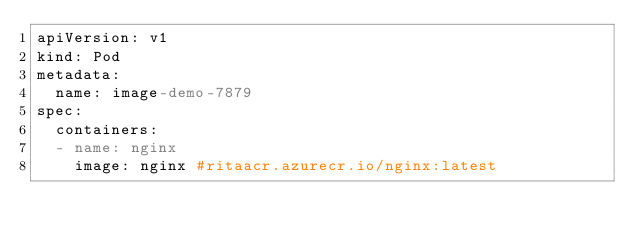Convert code to text. <code><loc_0><loc_0><loc_500><loc_500><_YAML_>apiVersion: v1
kind: Pod
metadata:
  name: image-demo-7879
spec:
  containers:
  - name: nginx
    image: nginx #ritaacr.azurecr.io/nginx:latest</code> 